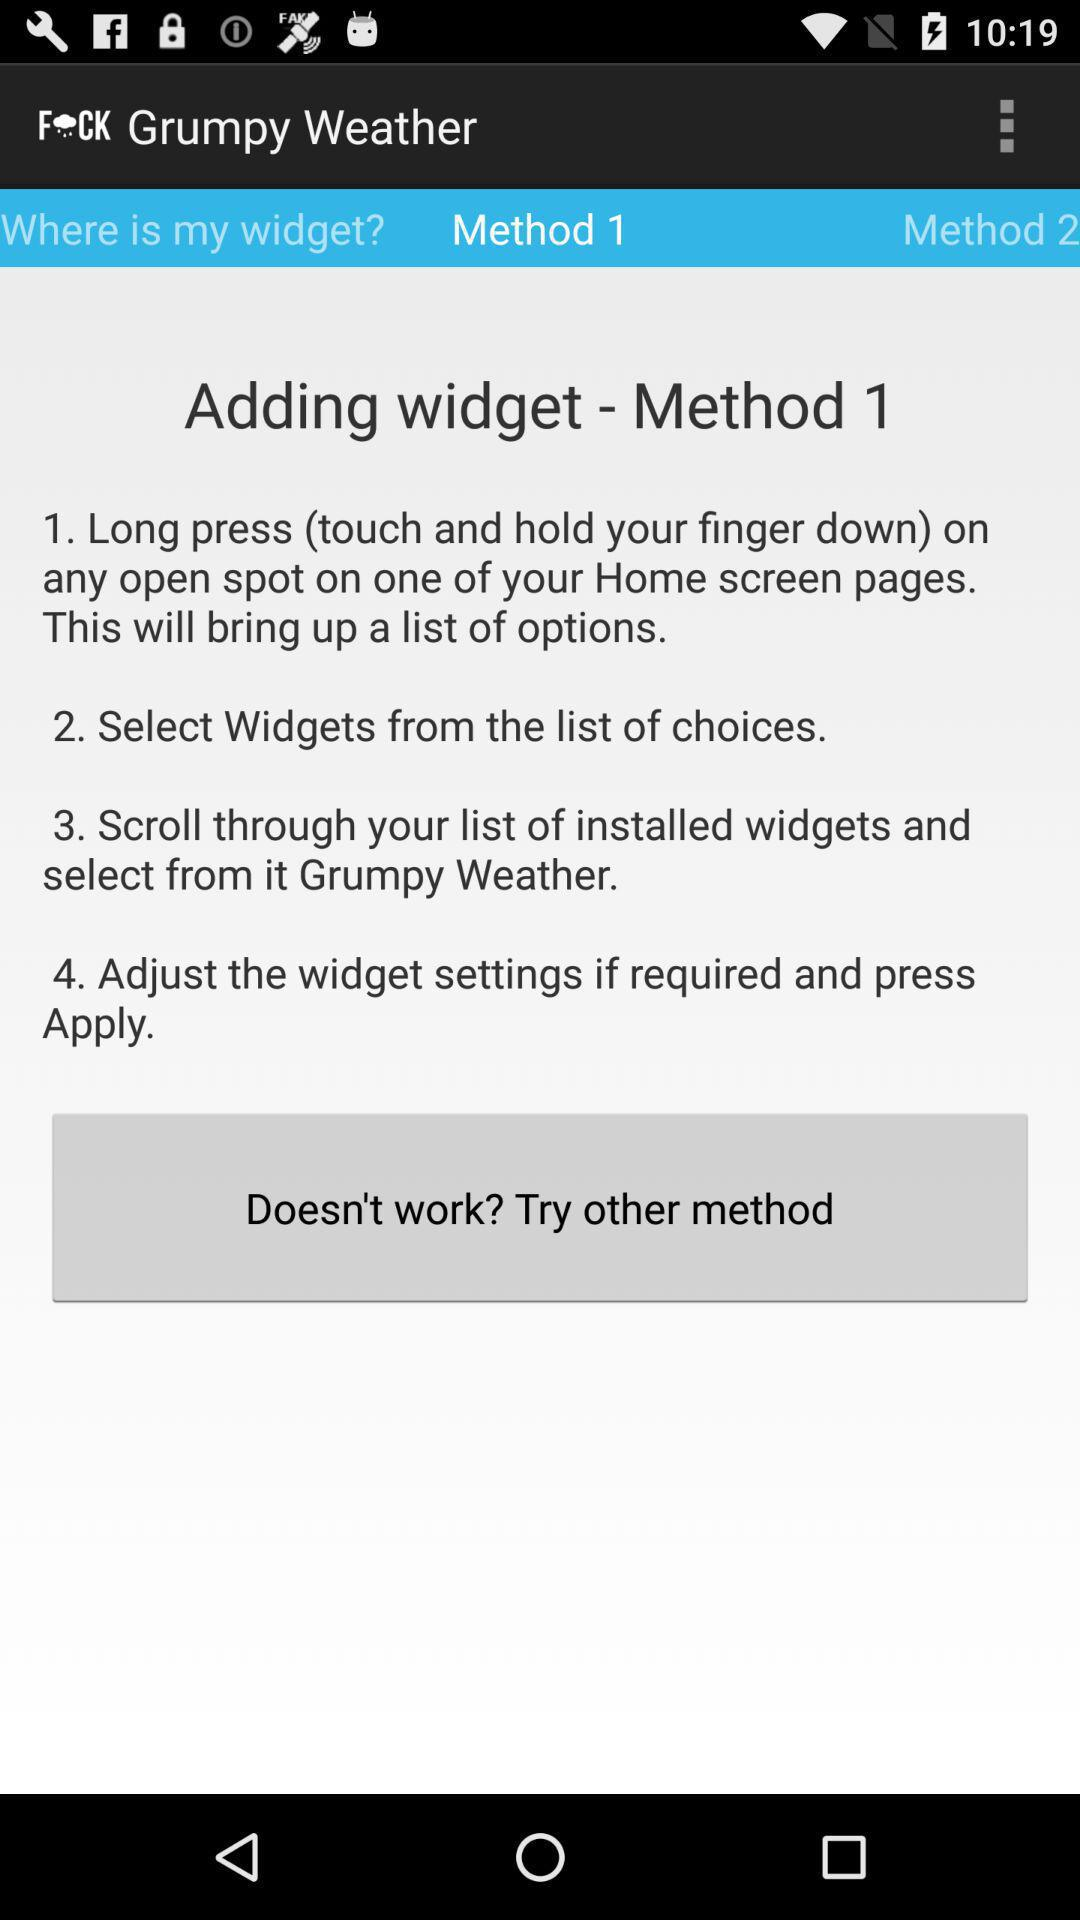How many steps are there in the first method?
Answer the question using a single word or phrase. 4 